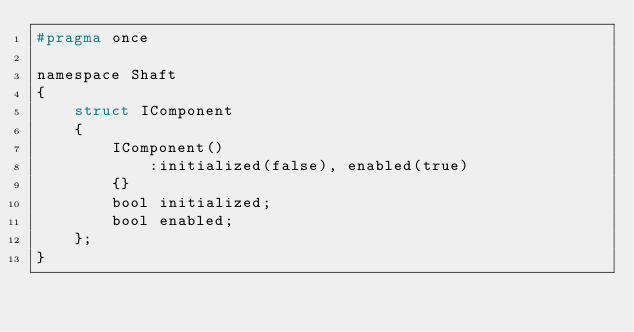Convert code to text. <code><loc_0><loc_0><loc_500><loc_500><_C_>#pragma once

namespace Shaft
{
	struct IComponent
	{
		IComponent()
			:initialized(false), enabled(true)
		{}
		bool initialized;
		bool enabled;
	};
}</code> 